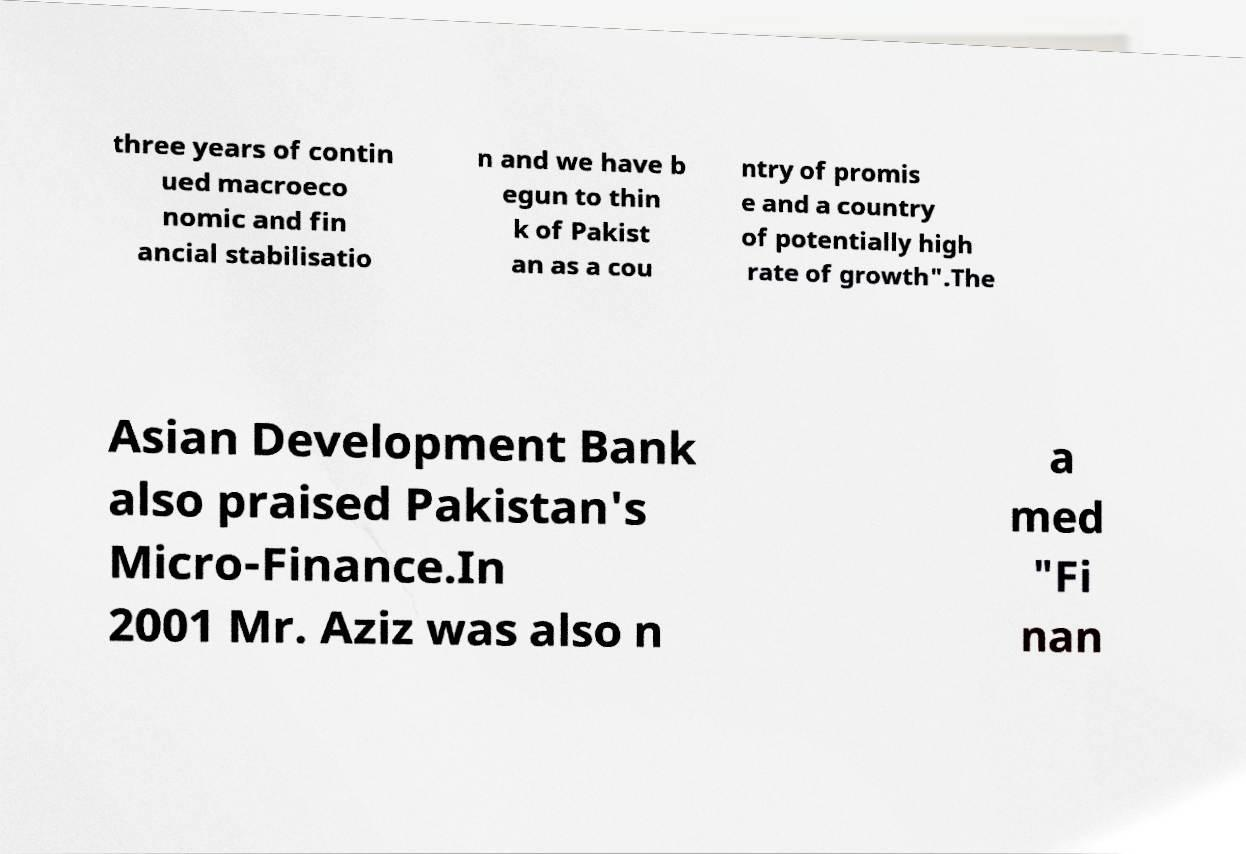Could you extract and type out the text from this image? three years of contin ued macroeco nomic and fin ancial stabilisatio n and we have b egun to thin k of Pakist an as a cou ntry of promis e and a country of potentially high rate of growth".The Asian Development Bank also praised Pakistan's Micro-Finance.In 2001 Mr. Aziz was also n a med "Fi nan 